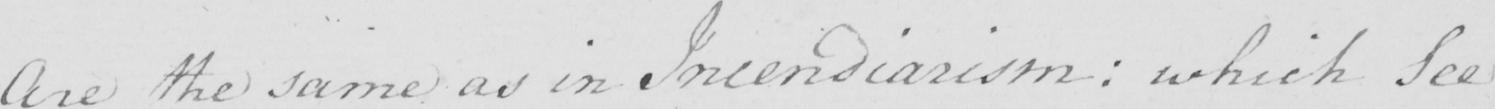Can you read and transcribe this handwriting? Are the same as in Incendiarism :  which See 